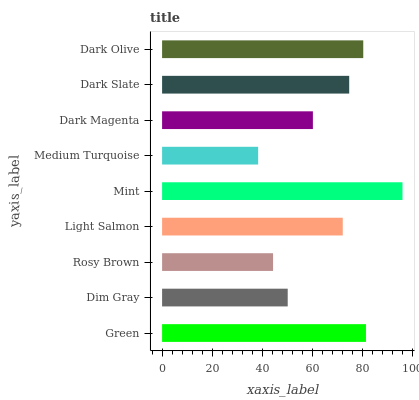Is Medium Turquoise the minimum?
Answer yes or no. Yes. Is Mint the maximum?
Answer yes or no. Yes. Is Dim Gray the minimum?
Answer yes or no. No. Is Dim Gray the maximum?
Answer yes or no. No. Is Green greater than Dim Gray?
Answer yes or no. Yes. Is Dim Gray less than Green?
Answer yes or no. Yes. Is Dim Gray greater than Green?
Answer yes or no. No. Is Green less than Dim Gray?
Answer yes or no. No. Is Light Salmon the high median?
Answer yes or no. Yes. Is Light Salmon the low median?
Answer yes or no. Yes. Is Dark Slate the high median?
Answer yes or no. No. Is Dark Magenta the low median?
Answer yes or no. No. 